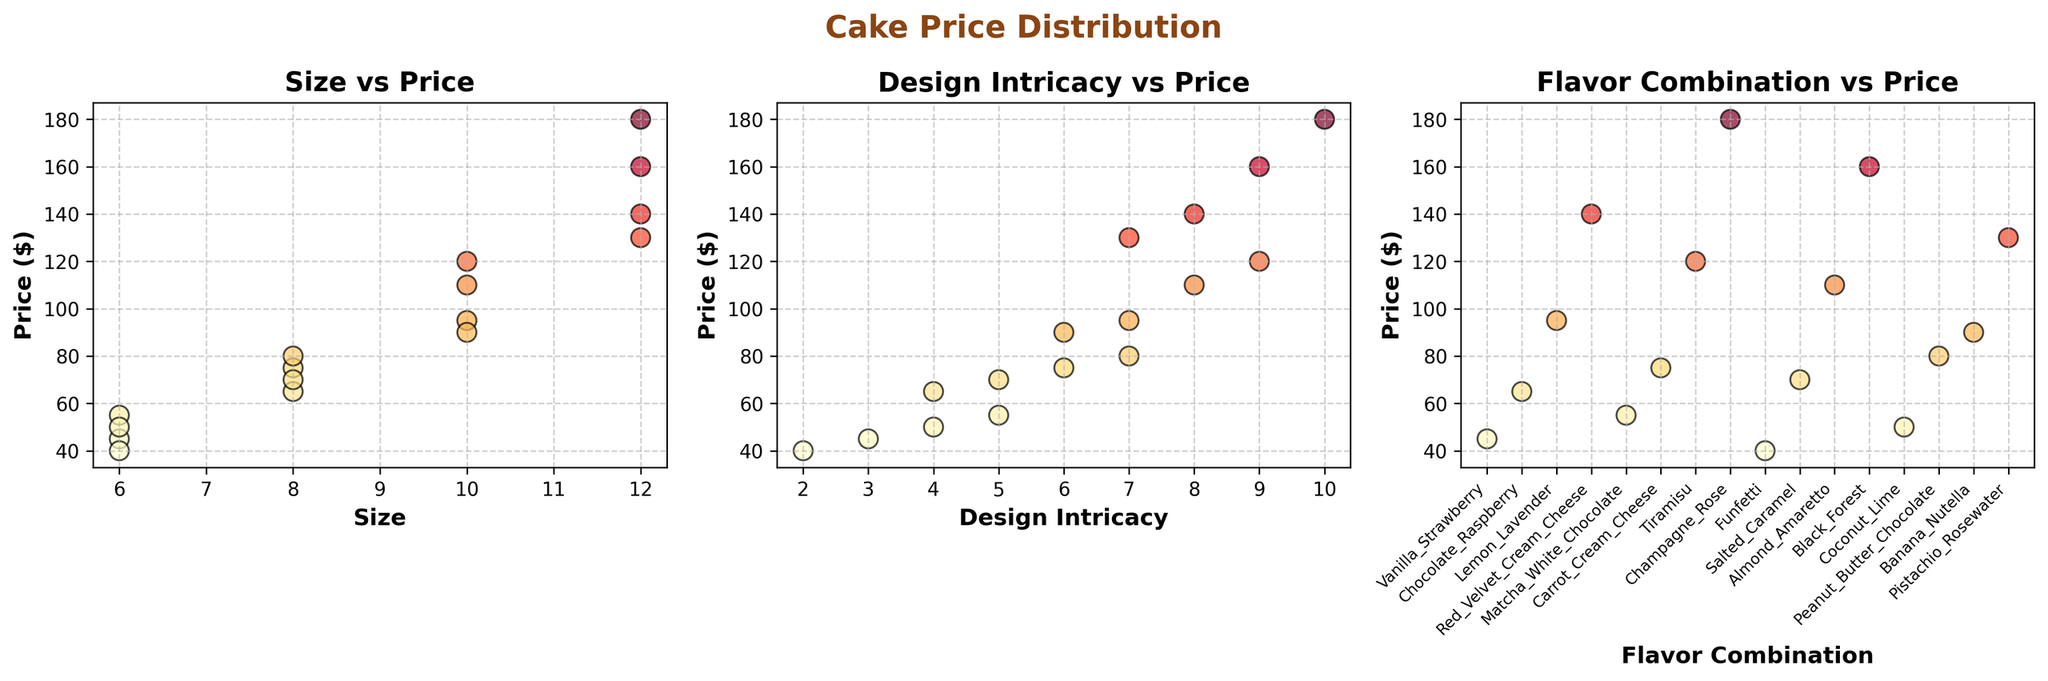How many data points are shown in the 'Size vs Price' plot? Count the number of 'Size' values plotted against 'Price' in the first subplot. There are 16 data points.
Answer: 16 Which plot shows the relationship between design intricacy and price? Identify the title of each subplot. The plot with the title 'Design Intricacy vs Price' shows this relationship.
Answer: 'Design Intricacy vs Price' What is the highest price for a cake, and in which plot can you find it? Look for the maximum 'Price' value across all three plots. The highest price is $180, found in all three plots.
Answer: $180 What is the relationship between 'Size' and 'Price' for cakes of size 12 inches? Examine the 'Size vs Price' plot and identify points where 'Size' is 12 inches. Notice the 'Price' values for these points (140, 160, 180). There seems to be a trend where the price increases with size.
Answer: Higher prices at 12 inches Which plot has the x-axis labeled with 'Flavor Combination'? Check the x-axis labels of all three subplots. The plot titled 'Flavor Combination vs Price' on the right has this x-axis label.
Answer: 'Flavor Combination vs Price' Does 'Design Intricacy' seem to impact 'Price'? Provide reasoning based on the visuals. In the 'Design Intricacy vs Price' plot, observe the trend where higher design intricacy seems correlated with higher prices.
Answer: Yes, higher intricacy often means higher price Compare the prices of cakes with a design intricacy rating of 5. Which flavor combinations are listed, and what are their prices? In the 'Design Intricacy vs Price' plot, locate points where 'Design Intricacy' is 5. Identify the corresponding 'Flavor Combination' and 'Price' from the 'Flavor Combination vs Price' plot. These are 'Matcha White Chocolate' ($55) and 'Salted Caramel' ($70).
Answer: Matcha White Chocolate ($55), Salted Caramel ($70) Which plot shows the highest level of detail in individual data points? Analyze the three subplots, noting which one has the most clearly distinguishable individual data points. The 'Flavor Combination vs Price' plot has detailed x-tick labels and individual markers for each data point.
Answer: 'Flavor Combination vs Price' Is there any flavor combination with a price exactly $110? Refer to the 'Flavor Combination vs Price' plot. The flavor combination with a price of $110 is 'Almond Amaretto'.
Answer: Almond Amaretto 